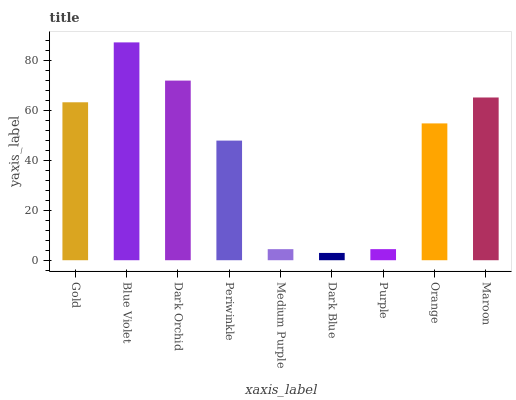Is Dark Blue the minimum?
Answer yes or no. Yes. Is Blue Violet the maximum?
Answer yes or no. Yes. Is Dark Orchid the minimum?
Answer yes or no. No. Is Dark Orchid the maximum?
Answer yes or no. No. Is Blue Violet greater than Dark Orchid?
Answer yes or no. Yes. Is Dark Orchid less than Blue Violet?
Answer yes or no. Yes. Is Dark Orchid greater than Blue Violet?
Answer yes or no. No. Is Blue Violet less than Dark Orchid?
Answer yes or no. No. Is Orange the high median?
Answer yes or no. Yes. Is Orange the low median?
Answer yes or no. Yes. Is Periwinkle the high median?
Answer yes or no. No. Is Medium Purple the low median?
Answer yes or no. No. 